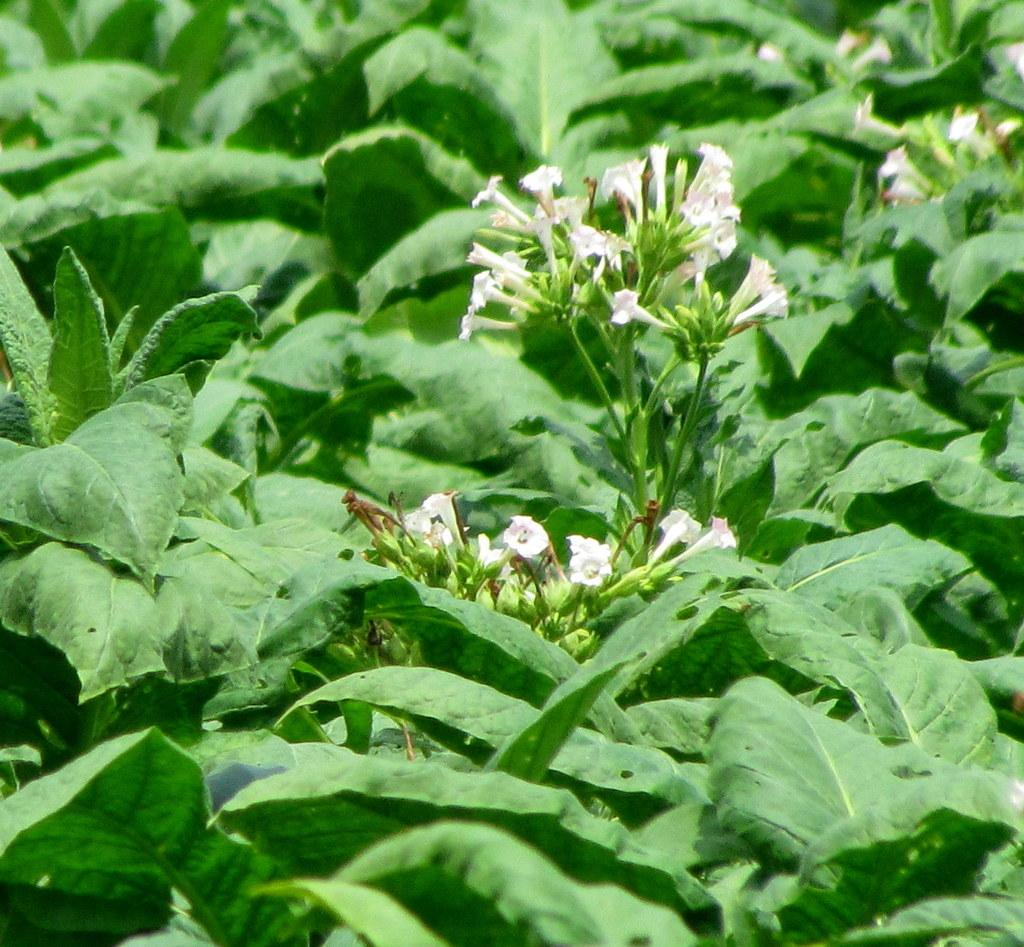What type of plant material can be seen in the image? There are leaves and flowers in the image. Can you describe the flowers in the image? Unfortunately, the facts provided do not give specific details about the flowers. What is the general setting or context of the image? The facts provided only mention the presence of leaves and flowers, so it is difficult to determine the context or setting of the image. How many pages are visible in the image? There are no pages present in the image; it features leaves and flowers. What color are the eyes of the corn in the image? There is no corn present in the image, and therefore no eyes to describe. 